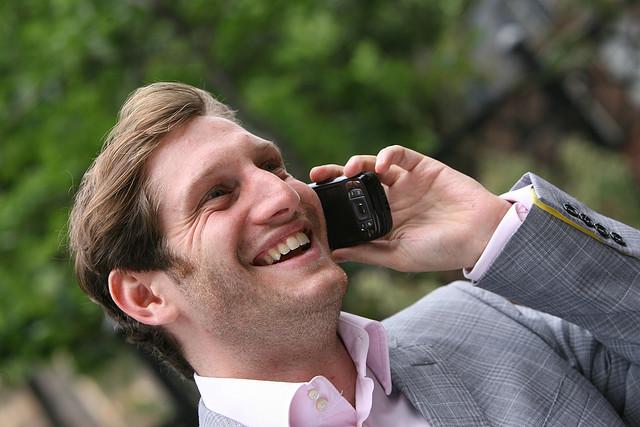Is the man smart?
Write a very short answer. Yes. What is in his left hand?
Be succinct. Cell phone. What color is his hair?
Short answer required. Brown. 